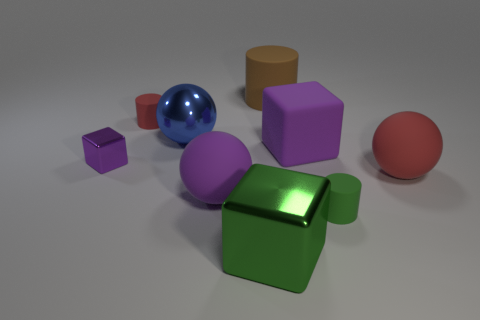Is the number of large red rubber objects that are to the left of the big red rubber ball the same as the number of large cyan metallic spheres?
Your answer should be very brief. Yes. There is a brown thing that is the same size as the green block; what shape is it?
Ensure brevity in your answer.  Cylinder. Is there a red object behind the small purple object that is behind the big green metallic cube?
Keep it short and to the point. Yes. How many tiny things are either red matte cylinders or red blocks?
Keep it short and to the point. 1. Are there any blue things that have the same size as the brown matte object?
Ensure brevity in your answer.  Yes. What number of matte objects are blue objects or big red things?
Offer a very short reply. 1. There is a small shiny thing that is the same color as the large rubber cube; what shape is it?
Offer a terse response. Cube. What number of large blue matte cylinders are there?
Ensure brevity in your answer.  0. Does the big cube that is behind the red ball have the same material as the small thing in front of the red ball?
Offer a very short reply. Yes. What is the size of the red cylinder that is the same material as the big purple ball?
Your answer should be compact. Small. 